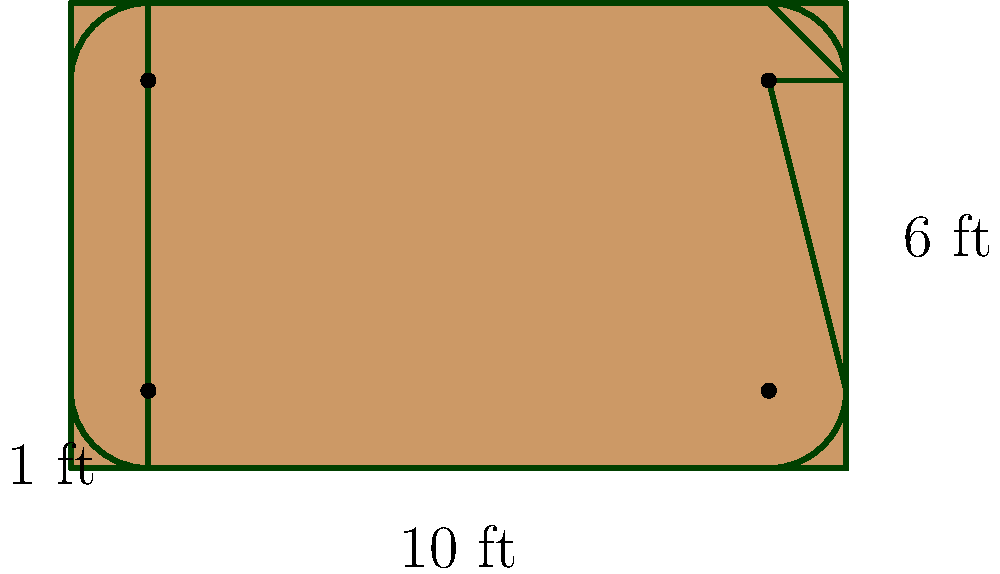You're crafting a rectangular wooden sign for the local farmers' market. The sign measures 10 feet wide by 6 feet tall, with rounded corners that have a radius of 1 foot. What's the total area of wood you'll need for this sign, rounded to the nearest square foot? Let's approach this step-by-step:

1) First, calculate the area of the full rectangle:
   $A_{rectangle} = 10 \text{ ft} \times 6 \text{ ft} = 60 \text{ sq ft}$

2) Now, we need to subtract the area of the four corners. Each corner is a quarter circle.

3) The area of a full circle with radius 1 ft is:
   $A_{circle} = \pi r^2 = \pi \times 1^2 = \pi \text{ sq ft}$

4) A quarter of this circle is:
   $A_{quarter} = \frac{\pi}{4} \text{ sq ft}$

5) We have four such quarters to subtract:
   $A_{corners} = 4 \times \frac{\pi}{4} = \pi \text{ sq ft}$

6) Therefore, the total area is:
   $A_{total} = A_{rectangle} - A_{corners} = 60 - \pi \text{ sq ft}$

7) Calculating this:
   $A_{total} = 60 - 3.14159... = 56.85840... \text{ sq ft}$

8) Rounding to the nearest square foot:
   $A_{total} \approx 57 \text{ sq ft}$
Answer: 57 sq ft 